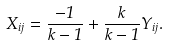<formula> <loc_0><loc_0><loc_500><loc_500>X _ { i j } = \frac { - 1 } { k - 1 } + \frac { k } { k - 1 } Y _ { i j } .</formula> 